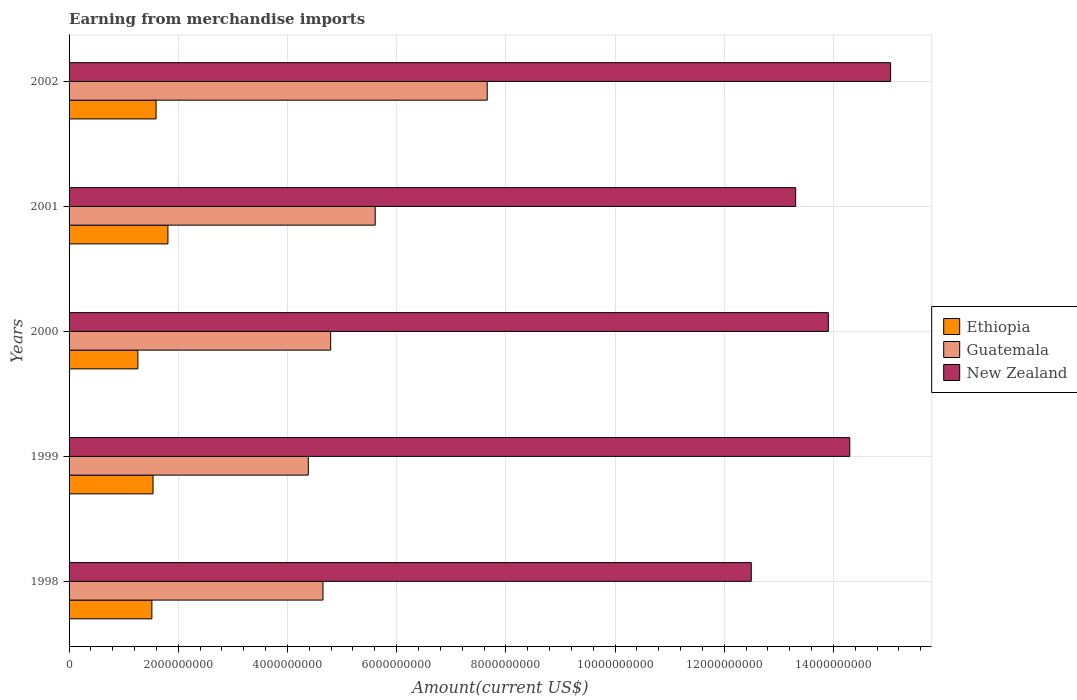Are the number of bars per tick equal to the number of legend labels?
Make the answer very short. Yes. How many bars are there on the 3rd tick from the top?
Your response must be concise. 3. What is the label of the 2nd group of bars from the top?
Ensure brevity in your answer.  2001. What is the amount earned from merchandise imports in Ethiopia in 1999?
Your response must be concise. 1.54e+09. Across all years, what is the maximum amount earned from merchandise imports in New Zealand?
Make the answer very short. 1.50e+1. Across all years, what is the minimum amount earned from merchandise imports in Guatemala?
Keep it short and to the point. 4.38e+09. In which year was the amount earned from merchandise imports in New Zealand maximum?
Your response must be concise. 2002. What is the total amount earned from merchandise imports in Ethiopia in the graph?
Provide a succinct answer. 7.72e+09. What is the difference between the amount earned from merchandise imports in Guatemala in 2001 and that in 2002?
Your response must be concise. -2.05e+09. What is the difference between the amount earned from merchandise imports in New Zealand in 1998 and the amount earned from merchandise imports in Guatemala in 2001?
Offer a terse response. 6.89e+09. What is the average amount earned from merchandise imports in New Zealand per year?
Your response must be concise. 1.38e+1. In the year 1998, what is the difference between the amount earned from merchandise imports in New Zealand and amount earned from merchandise imports in Ethiopia?
Make the answer very short. 1.10e+1. In how many years, is the amount earned from merchandise imports in Guatemala greater than 2800000000 US$?
Offer a terse response. 5. What is the ratio of the amount earned from merchandise imports in Ethiopia in 2000 to that in 2002?
Your answer should be very brief. 0.79. Is the amount earned from merchandise imports in Ethiopia in 1998 less than that in 2001?
Ensure brevity in your answer.  Yes. Is the difference between the amount earned from merchandise imports in New Zealand in 1998 and 2002 greater than the difference between the amount earned from merchandise imports in Ethiopia in 1998 and 2002?
Keep it short and to the point. No. What is the difference between the highest and the second highest amount earned from merchandise imports in New Zealand?
Ensure brevity in your answer.  7.48e+08. What is the difference between the highest and the lowest amount earned from merchandise imports in Guatemala?
Give a very brief answer. 3.28e+09. In how many years, is the amount earned from merchandise imports in Ethiopia greater than the average amount earned from merchandise imports in Ethiopia taken over all years?
Offer a very short reply. 2. Is the sum of the amount earned from merchandise imports in Ethiopia in 1998 and 2002 greater than the maximum amount earned from merchandise imports in New Zealand across all years?
Your answer should be compact. No. What does the 3rd bar from the top in 2002 represents?
Make the answer very short. Ethiopia. What does the 1st bar from the bottom in 2001 represents?
Provide a short and direct response. Ethiopia. Is it the case that in every year, the sum of the amount earned from merchandise imports in Guatemala and amount earned from merchandise imports in New Zealand is greater than the amount earned from merchandise imports in Ethiopia?
Your answer should be very brief. Yes. What is the difference between two consecutive major ticks on the X-axis?
Provide a short and direct response. 2.00e+09. How many legend labels are there?
Give a very brief answer. 3. How are the legend labels stacked?
Keep it short and to the point. Vertical. What is the title of the graph?
Your response must be concise. Earning from merchandise imports. Does "OECD members" appear as one of the legend labels in the graph?
Your response must be concise. No. What is the label or title of the X-axis?
Provide a succinct answer. Amount(current US$). What is the Amount(current US$) in Ethiopia in 1998?
Provide a succinct answer. 1.52e+09. What is the Amount(current US$) in Guatemala in 1998?
Provide a succinct answer. 4.65e+09. What is the Amount(current US$) of New Zealand in 1998?
Offer a terse response. 1.25e+1. What is the Amount(current US$) of Ethiopia in 1999?
Offer a very short reply. 1.54e+09. What is the Amount(current US$) in Guatemala in 1999?
Provide a short and direct response. 4.38e+09. What is the Amount(current US$) of New Zealand in 1999?
Make the answer very short. 1.43e+1. What is the Amount(current US$) in Ethiopia in 2000?
Your answer should be compact. 1.26e+09. What is the Amount(current US$) of Guatemala in 2000?
Ensure brevity in your answer.  4.79e+09. What is the Amount(current US$) in New Zealand in 2000?
Offer a terse response. 1.39e+1. What is the Amount(current US$) in Ethiopia in 2001?
Offer a terse response. 1.81e+09. What is the Amount(current US$) of Guatemala in 2001?
Make the answer very short. 5.61e+09. What is the Amount(current US$) of New Zealand in 2001?
Offer a terse response. 1.33e+1. What is the Amount(current US$) in Ethiopia in 2002?
Your response must be concise. 1.59e+09. What is the Amount(current US$) in Guatemala in 2002?
Your answer should be very brief. 7.66e+09. What is the Amount(current US$) in New Zealand in 2002?
Make the answer very short. 1.50e+1. Across all years, what is the maximum Amount(current US$) in Ethiopia?
Your response must be concise. 1.81e+09. Across all years, what is the maximum Amount(current US$) of Guatemala?
Ensure brevity in your answer.  7.66e+09. Across all years, what is the maximum Amount(current US$) in New Zealand?
Your response must be concise. 1.50e+1. Across all years, what is the minimum Amount(current US$) of Ethiopia?
Your answer should be compact. 1.26e+09. Across all years, what is the minimum Amount(current US$) in Guatemala?
Ensure brevity in your answer.  4.38e+09. Across all years, what is the minimum Amount(current US$) of New Zealand?
Ensure brevity in your answer.  1.25e+1. What is the total Amount(current US$) in Ethiopia in the graph?
Ensure brevity in your answer.  7.72e+09. What is the total Amount(current US$) of Guatemala in the graph?
Ensure brevity in your answer.  2.71e+1. What is the total Amount(current US$) of New Zealand in the graph?
Provide a short and direct response. 6.91e+1. What is the difference between the Amount(current US$) in Ethiopia in 1998 and that in 1999?
Your answer should be compact. -2.12e+07. What is the difference between the Amount(current US$) of Guatemala in 1998 and that in 1999?
Your response must be concise. 2.69e+08. What is the difference between the Amount(current US$) in New Zealand in 1998 and that in 1999?
Your answer should be compact. -1.80e+09. What is the difference between the Amount(current US$) in Ethiopia in 1998 and that in 2000?
Provide a succinct answer. 2.56e+08. What is the difference between the Amount(current US$) in Guatemala in 1998 and that in 2000?
Make the answer very short. -1.40e+08. What is the difference between the Amount(current US$) in New Zealand in 1998 and that in 2000?
Give a very brief answer. -1.41e+09. What is the difference between the Amount(current US$) of Ethiopia in 1998 and that in 2001?
Provide a succinct answer. -2.94e+08. What is the difference between the Amount(current US$) of Guatemala in 1998 and that in 2001?
Your answer should be very brief. -9.56e+08. What is the difference between the Amount(current US$) of New Zealand in 1998 and that in 2001?
Your response must be concise. -8.13e+08. What is the difference between the Amount(current US$) in Ethiopia in 1998 and that in 2002?
Your answer should be very brief. -7.69e+07. What is the difference between the Amount(current US$) of Guatemala in 1998 and that in 2002?
Offer a very short reply. -3.01e+09. What is the difference between the Amount(current US$) of New Zealand in 1998 and that in 2002?
Your response must be concise. -2.55e+09. What is the difference between the Amount(current US$) in Ethiopia in 1999 and that in 2000?
Offer a terse response. 2.77e+08. What is the difference between the Amount(current US$) in Guatemala in 1999 and that in 2000?
Offer a terse response. -4.09e+08. What is the difference between the Amount(current US$) of New Zealand in 1999 and that in 2000?
Make the answer very short. 3.93e+08. What is the difference between the Amount(current US$) of Ethiopia in 1999 and that in 2001?
Provide a short and direct response. -2.73e+08. What is the difference between the Amount(current US$) of Guatemala in 1999 and that in 2001?
Your response must be concise. -1.22e+09. What is the difference between the Amount(current US$) in New Zealand in 1999 and that in 2001?
Make the answer very short. 9.91e+08. What is the difference between the Amount(current US$) of Ethiopia in 1999 and that in 2002?
Your response must be concise. -5.58e+07. What is the difference between the Amount(current US$) in Guatemala in 1999 and that in 2002?
Keep it short and to the point. -3.28e+09. What is the difference between the Amount(current US$) in New Zealand in 1999 and that in 2002?
Make the answer very short. -7.48e+08. What is the difference between the Amount(current US$) in Ethiopia in 2000 and that in 2001?
Ensure brevity in your answer.  -5.51e+08. What is the difference between the Amount(current US$) in Guatemala in 2000 and that in 2001?
Provide a succinct answer. -8.16e+08. What is the difference between the Amount(current US$) in New Zealand in 2000 and that in 2001?
Offer a very short reply. 5.98e+08. What is the difference between the Amount(current US$) in Ethiopia in 2000 and that in 2002?
Offer a very short reply. -3.33e+08. What is the difference between the Amount(current US$) of Guatemala in 2000 and that in 2002?
Your answer should be compact. -2.87e+09. What is the difference between the Amount(current US$) of New Zealand in 2000 and that in 2002?
Keep it short and to the point. -1.14e+09. What is the difference between the Amount(current US$) in Ethiopia in 2001 and that in 2002?
Ensure brevity in your answer.  2.17e+08. What is the difference between the Amount(current US$) of Guatemala in 2001 and that in 2002?
Offer a terse response. -2.05e+09. What is the difference between the Amount(current US$) in New Zealand in 2001 and that in 2002?
Offer a terse response. -1.74e+09. What is the difference between the Amount(current US$) of Ethiopia in 1998 and the Amount(current US$) of Guatemala in 1999?
Your response must be concise. -2.87e+09. What is the difference between the Amount(current US$) in Ethiopia in 1998 and the Amount(current US$) in New Zealand in 1999?
Your answer should be very brief. -1.28e+1. What is the difference between the Amount(current US$) in Guatemala in 1998 and the Amount(current US$) in New Zealand in 1999?
Ensure brevity in your answer.  -9.65e+09. What is the difference between the Amount(current US$) in Ethiopia in 1998 and the Amount(current US$) in Guatemala in 2000?
Your answer should be compact. -3.27e+09. What is the difference between the Amount(current US$) of Ethiopia in 1998 and the Amount(current US$) of New Zealand in 2000?
Offer a very short reply. -1.24e+1. What is the difference between the Amount(current US$) in Guatemala in 1998 and the Amount(current US$) in New Zealand in 2000?
Your answer should be compact. -9.26e+09. What is the difference between the Amount(current US$) in Ethiopia in 1998 and the Amount(current US$) in Guatemala in 2001?
Give a very brief answer. -4.09e+09. What is the difference between the Amount(current US$) of Ethiopia in 1998 and the Amount(current US$) of New Zealand in 2001?
Offer a very short reply. -1.18e+1. What is the difference between the Amount(current US$) of Guatemala in 1998 and the Amount(current US$) of New Zealand in 2001?
Your answer should be very brief. -8.66e+09. What is the difference between the Amount(current US$) of Ethiopia in 1998 and the Amount(current US$) of Guatemala in 2002?
Provide a short and direct response. -6.14e+09. What is the difference between the Amount(current US$) in Ethiopia in 1998 and the Amount(current US$) in New Zealand in 2002?
Your response must be concise. -1.35e+1. What is the difference between the Amount(current US$) of Guatemala in 1998 and the Amount(current US$) of New Zealand in 2002?
Provide a succinct answer. -1.04e+1. What is the difference between the Amount(current US$) in Ethiopia in 1999 and the Amount(current US$) in Guatemala in 2000?
Make the answer very short. -3.25e+09. What is the difference between the Amount(current US$) of Ethiopia in 1999 and the Amount(current US$) of New Zealand in 2000?
Your answer should be compact. -1.24e+1. What is the difference between the Amount(current US$) of Guatemala in 1999 and the Amount(current US$) of New Zealand in 2000?
Provide a succinct answer. -9.52e+09. What is the difference between the Amount(current US$) in Ethiopia in 1999 and the Amount(current US$) in Guatemala in 2001?
Provide a succinct answer. -4.07e+09. What is the difference between the Amount(current US$) in Ethiopia in 1999 and the Amount(current US$) in New Zealand in 2001?
Offer a very short reply. -1.18e+1. What is the difference between the Amount(current US$) of Guatemala in 1999 and the Amount(current US$) of New Zealand in 2001?
Your answer should be compact. -8.93e+09. What is the difference between the Amount(current US$) of Ethiopia in 1999 and the Amount(current US$) of Guatemala in 2002?
Your answer should be very brief. -6.12e+09. What is the difference between the Amount(current US$) of Ethiopia in 1999 and the Amount(current US$) of New Zealand in 2002?
Your answer should be very brief. -1.35e+1. What is the difference between the Amount(current US$) in Guatemala in 1999 and the Amount(current US$) in New Zealand in 2002?
Ensure brevity in your answer.  -1.07e+1. What is the difference between the Amount(current US$) of Ethiopia in 2000 and the Amount(current US$) of Guatemala in 2001?
Your response must be concise. -4.35e+09. What is the difference between the Amount(current US$) of Ethiopia in 2000 and the Amount(current US$) of New Zealand in 2001?
Give a very brief answer. -1.20e+1. What is the difference between the Amount(current US$) of Guatemala in 2000 and the Amount(current US$) of New Zealand in 2001?
Offer a terse response. -8.52e+09. What is the difference between the Amount(current US$) in Ethiopia in 2000 and the Amount(current US$) in Guatemala in 2002?
Your response must be concise. -6.40e+09. What is the difference between the Amount(current US$) in Ethiopia in 2000 and the Amount(current US$) in New Zealand in 2002?
Your response must be concise. -1.38e+1. What is the difference between the Amount(current US$) in Guatemala in 2000 and the Amount(current US$) in New Zealand in 2002?
Your answer should be compact. -1.03e+1. What is the difference between the Amount(current US$) of Ethiopia in 2001 and the Amount(current US$) of Guatemala in 2002?
Keep it short and to the point. -5.85e+09. What is the difference between the Amount(current US$) in Ethiopia in 2001 and the Amount(current US$) in New Zealand in 2002?
Give a very brief answer. -1.32e+1. What is the difference between the Amount(current US$) of Guatemala in 2001 and the Amount(current US$) of New Zealand in 2002?
Provide a succinct answer. -9.44e+09. What is the average Amount(current US$) of Ethiopia per year?
Keep it short and to the point. 1.54e+09. What is the average Amount(current US$) in Guatemala per year?
Offer a very short reply. 5.42e+09. What is the average Amount(current US$) of New Zealand per year?
Offer a terse response. 1.38e+1. In the year 1998, what is the difference between the Amount(current US$) in Ethiopia and Amount(current US$) in Guatemala?
Offer a very short reply. -3.13e+09. In the year 1998, what is the difference between the Amount(current US$) in Ethiopia and Amount(current US$) in New Zealand?
Your answer should be compact. -1.10e+1. In the year 1998, what is the difference between the Amount(current US$) in Guatemala and Amount(current US$) in New Zealand?
Offer a terse response. -7.84e+09. In the year 1999, what is the difference between the Amount(current US$) in Ethiopia and Amount(current US$) in Guatemala?
Offer a terse response. -2.84e+09. In the year 1999, what is the difference between the Amount(current US$) in Ethiopia and Amount(current US$) in New Zealand?
Keep it short and to the point. -1.28e+1. In the year 1999, what is the difference between the Amount(current US$) of Guatemala and Amount(current US$) of New Zealand?
Keep it short and to the point. -9.92e+09. In the year 2000, what is the difference between the Amount(current US$) in Ethiopia and Amount(current US$) in Guatemala?
Keep it short and to the point. -3.53e+09. In the year 2000, what is the difference between the Amount(current US$) in Ethiopia and Amount(current US$) in New Zealand?
Make the answer very short. -1.26e+1. In the year 2000, what is the difference between the Amount(current US$) of Guatemala and Amount(current US$) of New Zealand?
Offer a very short reply. -9.12e+09. In the year 2001, what is the difference between the Amount(current US$) in Ethiopia and Amount(current US$) in Guatemala?
Ensure brevity in your answer.  -3.80e+09. In the year 2001, what is the difference between the Amount(current US$) of Ethiopia and Amount(current US$) of New Zealand?
Provide a short and direct response. -1.15e+1. In the year 2001, what is the difference between the Amount(current US$) of Guatemala and Amount(current US$) of New Zealand?
Provide a short and direct response. -7.70e+09. In the year 2002, what is the difference between the Amount(current US$) in Ethiopia and Amount(current US$) in Guatemala?
Keep it short and to the point. -6.07e+09. In the year 2002, what is the difference between the Amount(current US$) of Ethiopia and Amount(current US$) of New Zealand?
Provide a succinct answer. -1.35e+1. In the year 2002, what is the difference between the Amount(current US$) in Guatemala and Amount(current US$) in New Zealand?
Your answer should be compact. -7.39e+09. What is the ratio of the Amount(current US$) of Ethiopia in 1998 to that in 1999?
Your response must be concise. 0.99. What is the ratio of the Amount(current US$) of Guatemala in 1998 to that in 1999?
Keep it short and to the point. 1.06. What is the ratio of the Amount(current US$) in New Zealand in 1998 to that in 1999?
Make the answer very short. 0.87. What is the ratio of the Amount(current US$) in Ethiopia in 1998 to that in 2000?
Your answer should be very brief. 1.2. What is the ratio of the Amount(current US$) in Guatemala in 1998 to that in 2000?
Give a very brief answer. 0.97. What is the ratio of the Amount(current US$) in New Zealand in 1998 to that in 2000?
Make the answer very short. 0.9. What is the ratio of the Amount(current US$) in Ethiopia in 1998 to that in 2001?
Make the answer very short. 0.84. What is the ratio of the Amount(current US$) in Guatemala in 1998 to that in 2001?
Provide a succinct answer. 0.83. What is the ratio of the Amount(current US$) of New Zealand in 1998 to that in 2001?
Offer a terse response. 0.94. What is the ratio of the Amount(current US$) of Ethiopia in 1998 to that in 2002?
Offer a terse response. 0.95. What is the ratio of the Amount(current US$) of Guatemala in 1998 to that in 2002?
Provide a short and direct response. 0.61. What is the ratio of the Amount(current US$) of New Zealand in 1998 to that in 2002?
Your answer should be compact. 0.83. What is the ratio of the Amount(current US$) of Ethiopia in 1999 to that in 2000?
Provide a short and direct response. 1.22. What is the ratio of the Amount(current US$) in Guatemala in 1999 to that in 2000?
Keep it short and to the point. 0.91. What is the ratio of the Amount(current US$) in New Zealand in 1999 to that in 2000?
Keep it short and to the point. 1.03. What is the ratio of the Amount(current US$) in Ethiopia in 1999 to that in 2001?
Your answer should be compact. 0.85. What is the ratio of the Amount(current US$) of Guatemala in 1999 to that in 2001?
Provide a succinct answer. 0.78. What is the ratio of the Amount(current US$) in New Zealand in 1999 to that in 2001?
Your response must be concise. 1.07. What is the ratio of the Amount(current US$) in Ethiopia in 1999 to that in 2002?
Provide a succinct answer. 0.96. What is the ratio of the Amount(current US$) in Guatemala in 1999 to that in 2002?
Keep it short and to the point. 0.57. What is the ratio of the Amount(current US$) of New Zealand in 1999 to that in 2002?
Provide a succinct answer. 0.95. What is the ratio of the Amount(current US$) of Ethiopia in 2000 to that in 2001?
Give a very brief answer. 0.7. What is the ratio of the Amount(current US$) in Guatemala in 2000 to that in 2001?
Provide a short and direct response. 0.85. What is the ratio of the Amount(current US$) in New Zealand in 2000 to that in 2001?
Offer a very short reply. 1.04. What is the ratio of the Amount(current US$) of Ethiopia in 2000 to that in 2002?
Offer a terse response. 0.79. What is the ratio of the Amount(current US$) of Guatemala in 2000 to that in 2002?
Your response must be concise. 0.63. What is the ratio of the Amount(current US$) in New Zealand in 2000 to that in 2002?
Ensure brevity in your answer.  0.92. What is the ratio of the Amount(current US$) of Ethiopia in 2001 to that in 2002?
Your answer should be very brief. 1.14. What is the ratio of the Amount(current US$) of Guatemala in 2001 to that in 2002?
Your answer should be very brief. 0.73. What is the ratio of the Amount(current US$) in New Zealand in 2001 to that in 2002?
Provide a succinct answer. 0.88. What is the difference between the highest and the second highest Amount(current US$) in Ethiopia?
Give a very brief answer. 2.17e+08. What is the difference between the highest and the second highest Amount(current US$) in Guatemala?
Ensure brevity in your answer.  2.05e+09. What is the difference between the highest and the second highest Amount(current US$) in New Zealand?
Provide a succinct answer. 7.48e+08. What is the difference between the highest and the lowest Amount(current US$) of Ethiopia?
Ensure brevity in your answer.  5.51e+08. What is the difference between the highest and the lowest Amount(current US$) of Guatemala?
Your response must be concise. 3.28e+09. What is the difference between the highest and the lowest Amount(current US$) of New Zealand?
Offer a very short reply. 2.55e+09. 